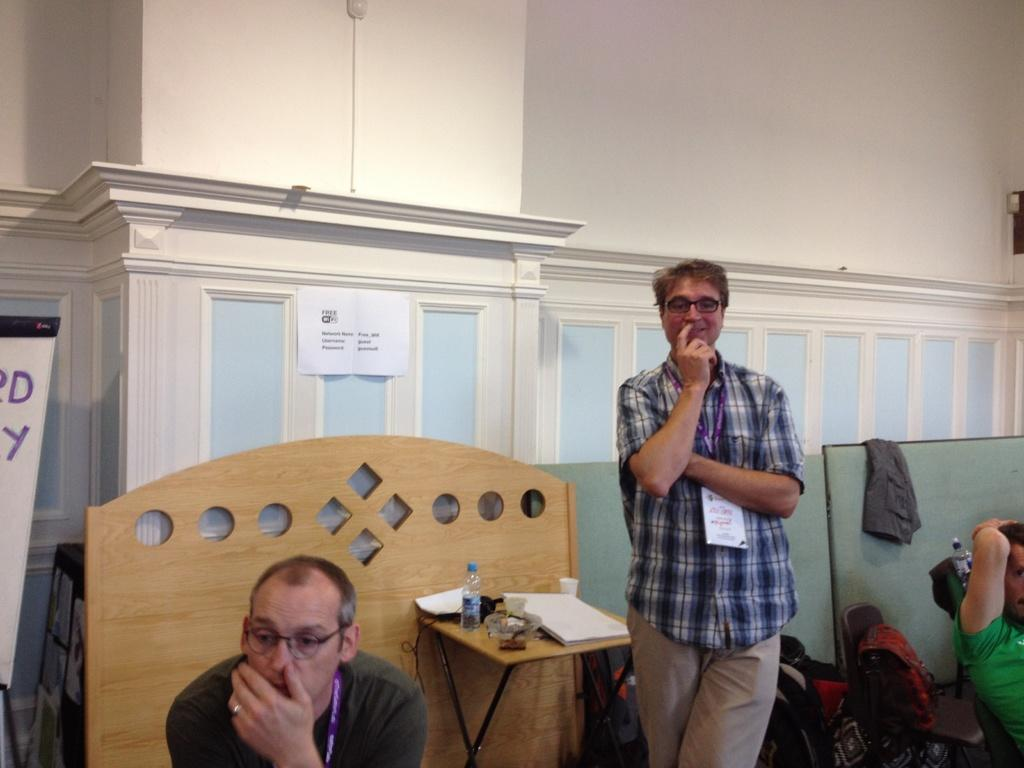What is the position of the man on the left side of the image? The man on the left side of the image is on the left side. What can be observed about the man on the left side in terms of his appearance? The man on the left side is wearing spectacles. What is the position of the man on the right side of the image? The man on the right side of the image is on the right side. What is the man on the right side doing? The man on the right side is standing and smiling. What type of protest is the woman leading in the image? There is no woman present in the image, and therefore no protest can be observed. 